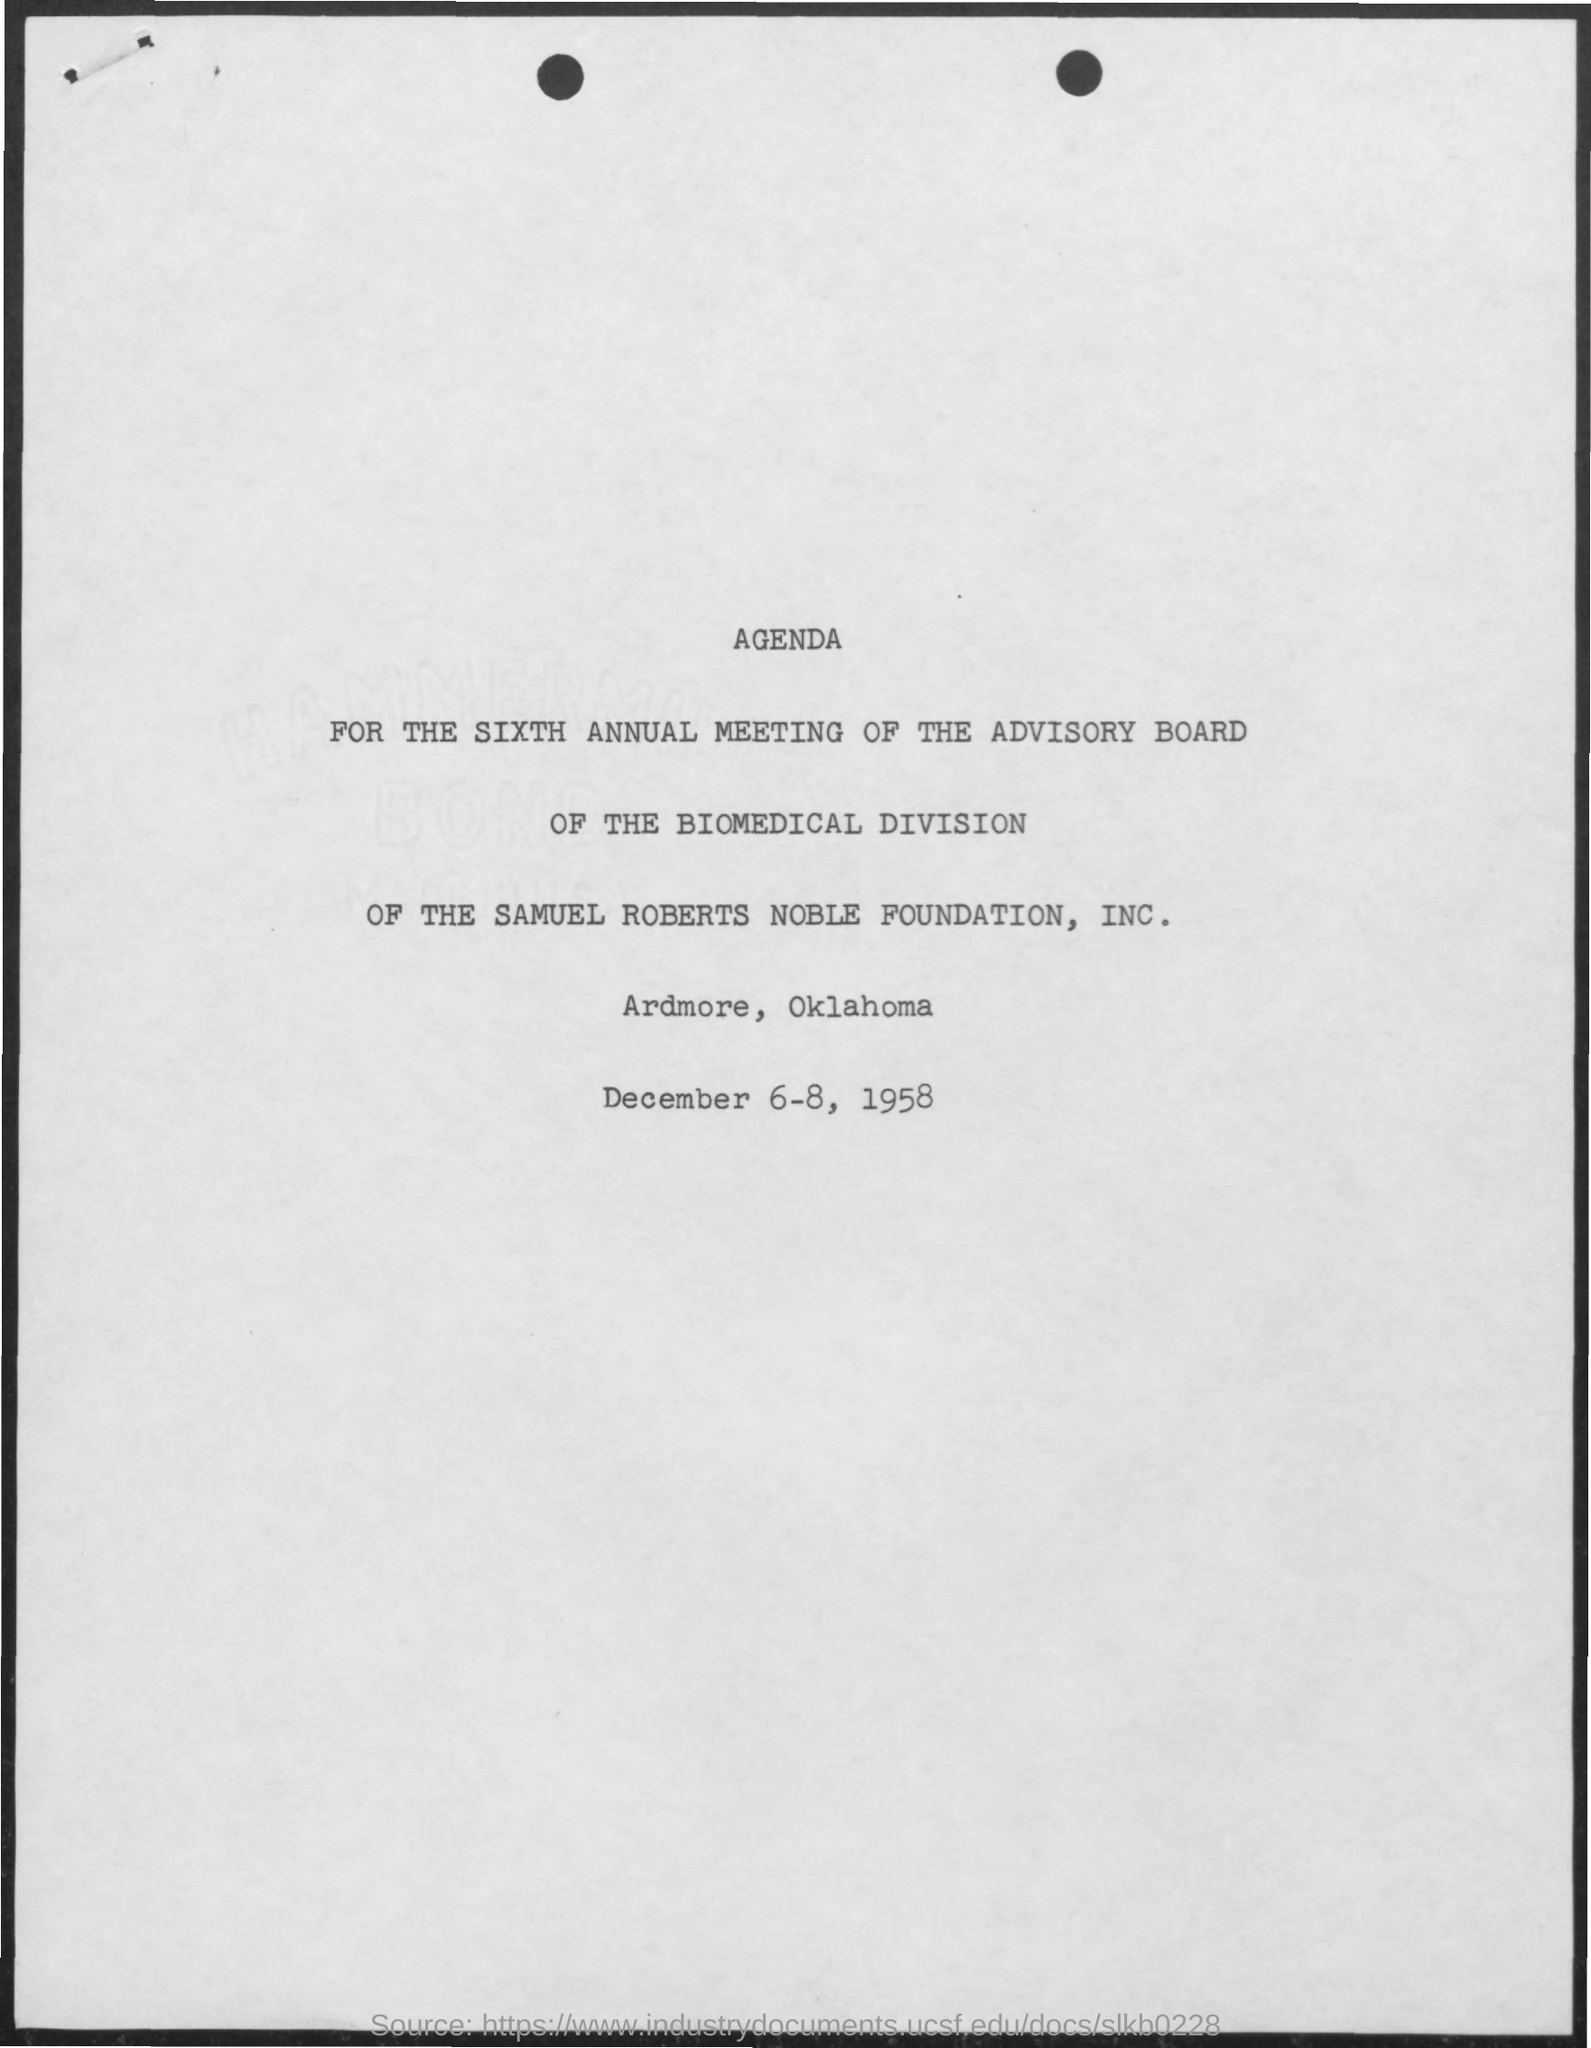What is the name of the division mentioned in the given page ?
Give a very brief answer. Biomedical division. What is the date mentioned in the given page ?
Offer a very short reply. December 6-8, 1958. What is the name of the foundation mentioned ?
Provide a short and direct response. Samuel roberts noble foundation, inc. 